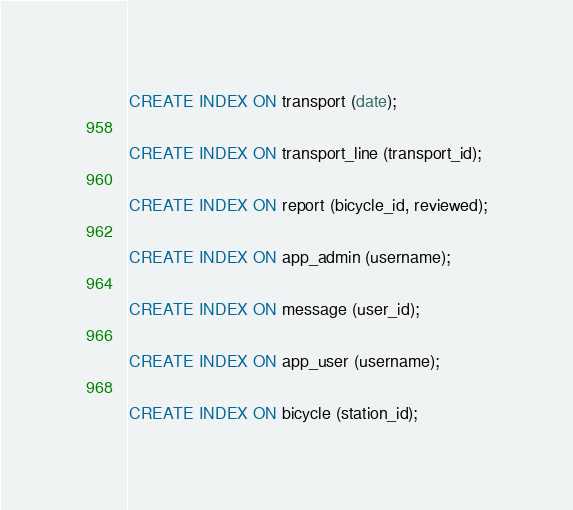<code> <loc_0><loc_0><loc_500><loc_500><_SQL_>CREATE INDEX ON transport (date);

CREATE INDEX ON transport_line (transport_id);

CREATE INDEX ON report (bicycle_id, reviewed);

CREATE INDEX ON app_admin (username);

CREATE INDEX ON message (user_id);

CREATE INDEX ON app_user (username);

CREATE INDEX ON bicycle (station_id);
</code> 